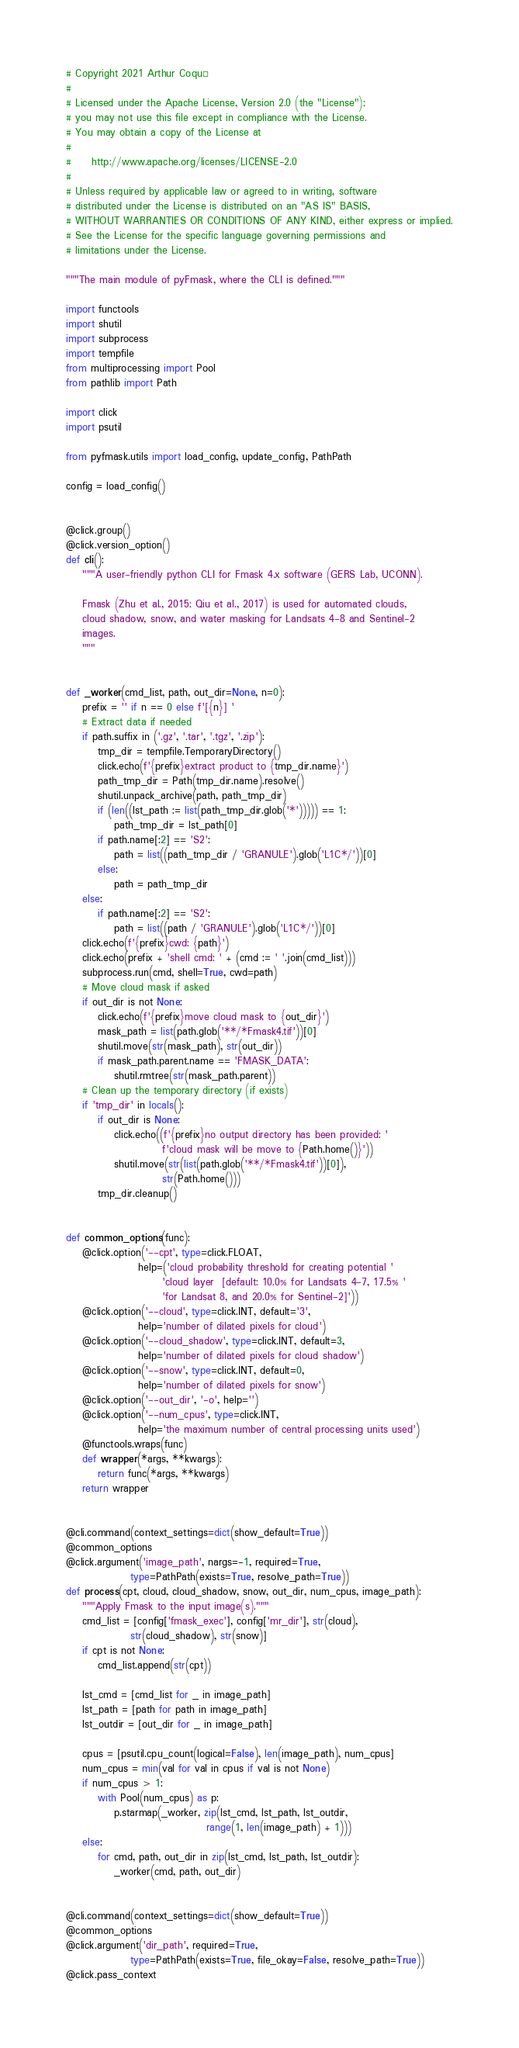Convert code to text. <code><loc_0><loc_0><loc_500><loc_500><_Python_># Copyright 2021 Arthur Coqué
#
# Licensed under the Apache License, Version 2.0 (the "License");
# you may not use this file except in compliance with the License.
# You may obtain a copy of the License at
#
#     http://www.apache.org/licenses/LICENSE-2.0
#
# Unless required by applicable law or agreed to in writing, software
# distributed under the License is distributed on an "AS IS" BASIS,
# WITHOUT WARRANTIES OR CONDITIONS OF ANY KIND, either express or implied.
# See the License for the specific language governing permissions and
# limitations under the License.

"""The main module of pyFmask, where the CLI is defined."""

import functools
import shutil
import subprocess
import tempfile
from multiprocessing import Pool
from pathlib import Path

import click
import psutil

from pyfmask.utils import load_config, update_config, PathPath

config = load_config()


@click.group()
@click.version_option()
def cli():
    """A user-friendly python CLI for Fmask 4.x software (GERS Lab, UCONN).
    
    Fmask (Zhu et al., 2015; Qiu et al., 2017) is used for automated clouds,
    cloud shadow, snow, and water masking for Landsats 4-8 and Sentinel-2
    images.
    """


def _worker(cmd_list, path, out_dir=None, n=0):
    prefix = '' if n == 0 else f'[{n}] '
    # Extract data if needed
    if path.suffix in ('.gz', '.tar', '.tgz', '.zip'):
        tmp_dir = tempfile.TemporaryDirectory()
        click.echo(f'{prefix}extract product to {tmp_dir.name}')
        path_tmp_dir = Path(tmp_dir.name).resolve()
        shutil.unpack_archive(path, path_tmp_dir)
        if (len((lst_path := list(path_tmp_dir.glob('*'))))) == 1:
            path_tmp_dir = lst_path[0]
        if path.name[:2] == 'S2':
            path = list((path_tmp_dir / 'GRANULE').glob('L1C*/'))[0]
        else:
            path = path_tmp_dir
    else:
        if path.name[:2] == 'S2':
            path = list((path / 'GRANULE').glob('L1C*/'))[0]
    click.echo(f'{prefix}cwd: {path}')
    click.echo(prefix + 'shell cmd: ' + (cmd := ' '.join(cmd_list)))
    subprocess.run(cmd, shell=True, cwd=path)
    # Move cloud mask if asked
    if out_dir is not None:
        click.echo(f'{prefix}move cloud mask to {out_dir}')
        mask_path = list(path.glob('**/*Fmask4.tif'))[0]
        shutil.move(str(mask_path), str(out_dir))
        if mask_path.parent.name == 'FMASK_DATA':
            shutil.rmtree(str(mask_path.parent))
    # Clean up the temporary directory (if exists)
    if 'tmp_dir' in locals():
        if out_dir is None:
            click.echo((f'{prefix}no output directory has been provided: '
                        f'cloud mask will be move to {Path.home()}'))
            shutil.move(str(list(path.glob('**/*Fmask4.tif'))[0]),
                        str(Path.home()))
        tmp_dir.cleanup()


def common_options(func):
    @click.option('--cpt', type=click.FLOAT,
                  help=('cloud probability threshold for creating potential '
                        'cloud layer  [default: 10.0% for Landsats 4-7, 17.5% '
                        'for Landsat 8, and 20.0% for Sentinel-2]'))
    @click.option('--cloud', type=click.INT, default='3',
                  help='number of dilated pixels for cloud')
    @click.option('--cloud_shadow', type=click.INT, default=3,
                  help='number of dilated pixels for cloud shadow')
    @click.option('--snow', type=click.INT, default=0,
                  help='number of dilated pixels for snow')
    @click.option('--out_dir', '-o', help='')
    @click.option('--num_cpus', type=click.INT,
                  help='the maximum number of central processing units used')
    @functools.wraps(func)
    def wrapper(*args, **kwargs):
        return func(*args, **kwargs)
    return wrapper


@cli.command(context_settings=dict(show_default=True))
@common_options
@click.argument('image_path', nargs=-1, required=True,
                type=PathPath(exists=True, resolve_path=True))
def process(cpt, cloud, cloud_shadow, snow, out_dir, num_cpus, image_path):
    """Apply Fmask to the input image(s)."""
    cmd_list = [config['fmask_exec'], config['mr_dir'], str(cloud),
                str(cloud_shadow), str(snow)]
    if cpt is not None:
        cmd_list.append(str(cpt))
    
    lst_cmd = [cmd_list for _ in image_path]
    lst_path = [path for path in image_path]
    lst_outdir = [out_dir for _ in image_path]
    
    cpus = [psutil.cpu_count(logical=False), len(image_path), num_cpus]
    num_cpus = min(val for val in cpus if val is not None)
    if num_cpus > 1:
        with Pool(num_cpus) as p:
            p.starmap(_worker, zip(lst_cmd, lst_path, lst_outdir,
                                   range(1, len(image_path) + 1)))
    else:
        for cmd, path, out_dir in zip(lst_cmd, lst_path, lst_outdir):
            _worker(cmd, path, out_dir)


@cli.command(context_settings=dict(show_default=True))
@common_options
@click.argument('dir_path', required=True,
                type=PathPath(exists=True, file_okay=False, resolve_path=True))
@click.pass_context</code> 